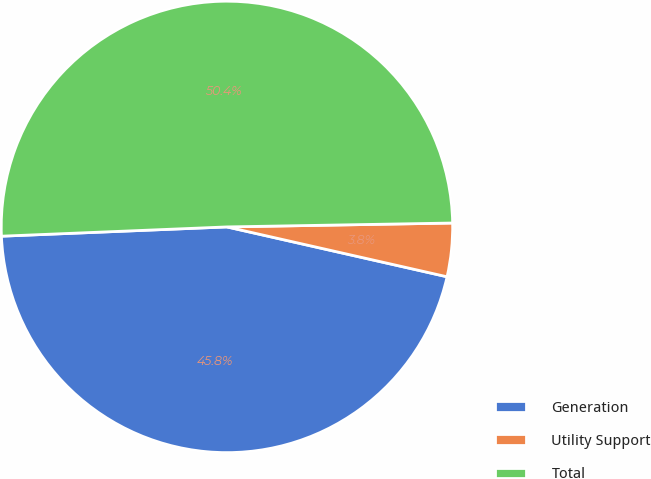Convert chart to OTSL. <chart><loc_0><loc_0><loc_500><loc_500><pie_chart><fcel>Generation<fcel>Utility Support<fcel>Total<nl><fcel>45.8%<fcel>3.82%<fcel>50.38%<nl></chart> 